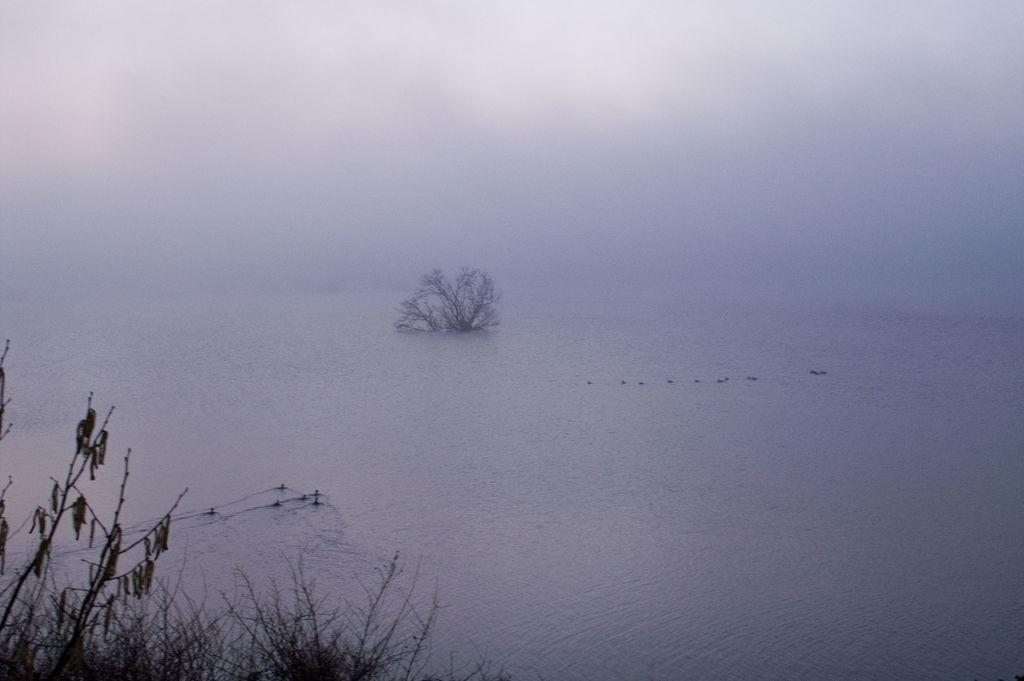What is the primary element visible in the image? There is water in the image. What type of vegetation can be seen in the image? Leaves and trees are visible in the image. How would you describe the appearance of the sky in the image? The sky appears smoky in the image. Where is the hydrant located in the image? There is no hydrant present in the image. What type of match can be seen in the image? There are no matches present in the image. 